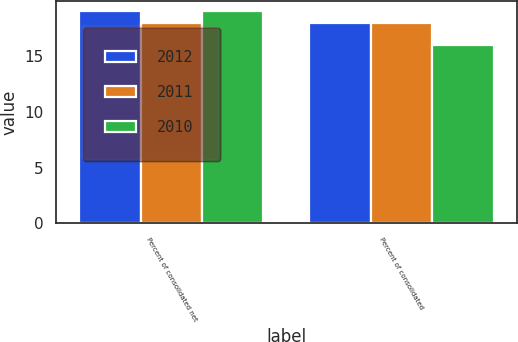Convert chart to OTSL. <chart><loc_0><loc_0><loc_500><loc_500><stacked_bar_chart><ecel><fcel>Percent of consolidated net<fcel>Percent of consolidated<nl><fcel>2012<fcel>19<fcel>18<nl><fcel>2011<fcel>18<fcel>18<nl><fcel>2010<fcel>19<fcel>16<nl></chart> 